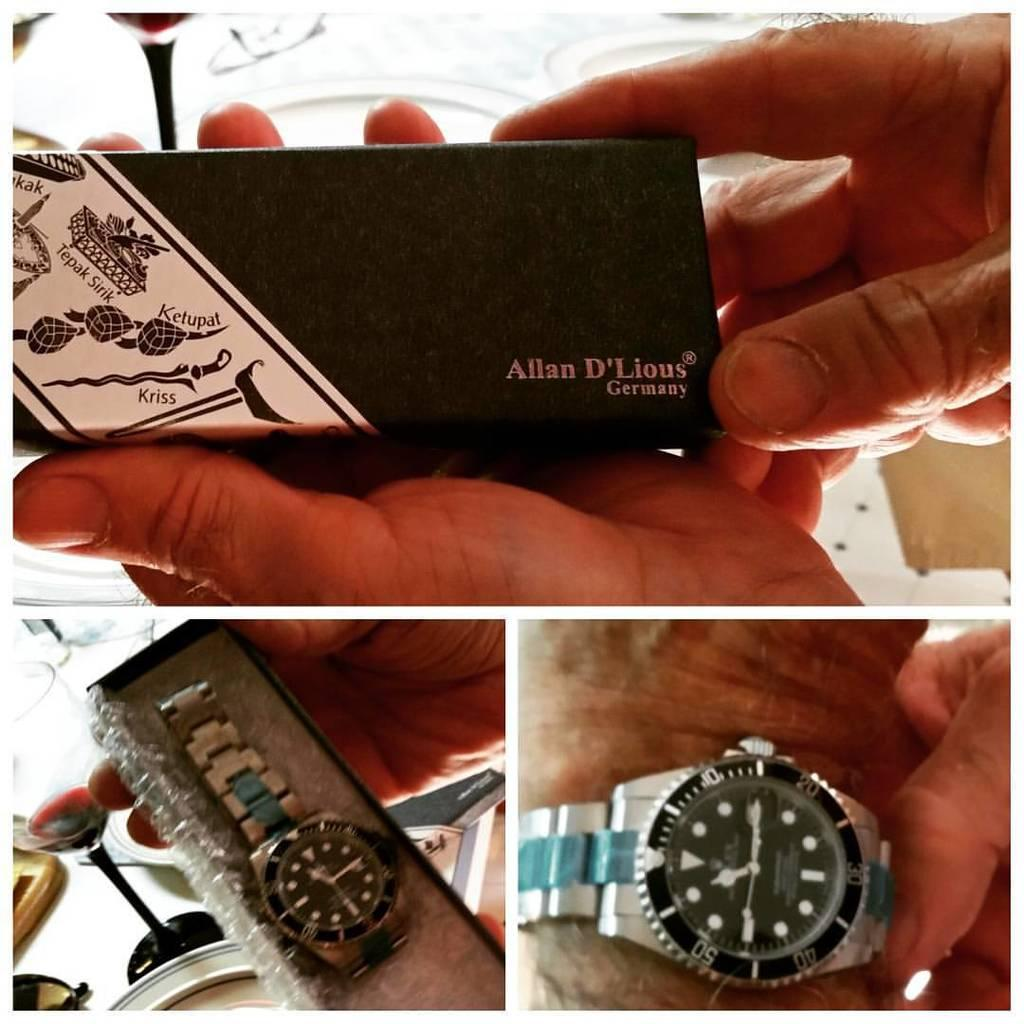<image>
Write a terse but informative summary of the picture. An Allan D'Lious brand wristwatch, shown in its packaging and on a man's arm. 